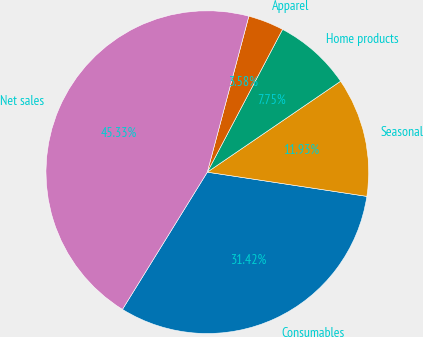Convert chart. <chart><loc_0><loc_0><loc_500><loc_500><pie_chart><fcel>Consumables<fcel>Seasonal<fcel>Home products<fcel>Apparel<fcel>Net sales<nl><fcel>31.42%<fcel>11.93%<fcel>7.75%<fcel>3.58%<fcel>45.33%<nl></chart> 